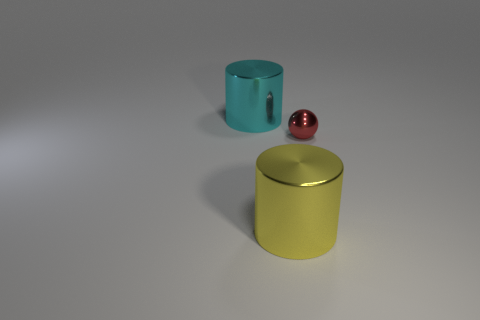There is a metal object that is behind the yellow thing and in front of the big cyan object; what shape is it?
Provide a short and direct response. Sphere. How many objects are cyan things or big objects on the left side of the big yellow cylinder?
Make the answer very short. 1. Does the red sphere have the same material as the big cyan cylinder?
Your answer should be compact. Yes. How many other objects are the same shape as the small red object?
Ensure brevity in your answer.  0. There is a object that is in front of the cyan metal cylinder and behind the big yellow object; what size is it?
Give a very brief answer. Small. What number of metal things are small cylinders or small red spheres?
Provide a succinct answer. 1. There is a big thing right of the cyan metal cylinder; is it the same shape as the metallic thing behind the small red ball?
Make the answer very short. Yes. Are there any cyan cylinders that have the same material as the red object?
Provide a succinct answer. Yes. What is the color of the small sphere?
Provide a short and direct response. Red. How big is the metallic cylinder that is on the right side of the cyan shiny thing?
Provide a short and direct response. Large. 